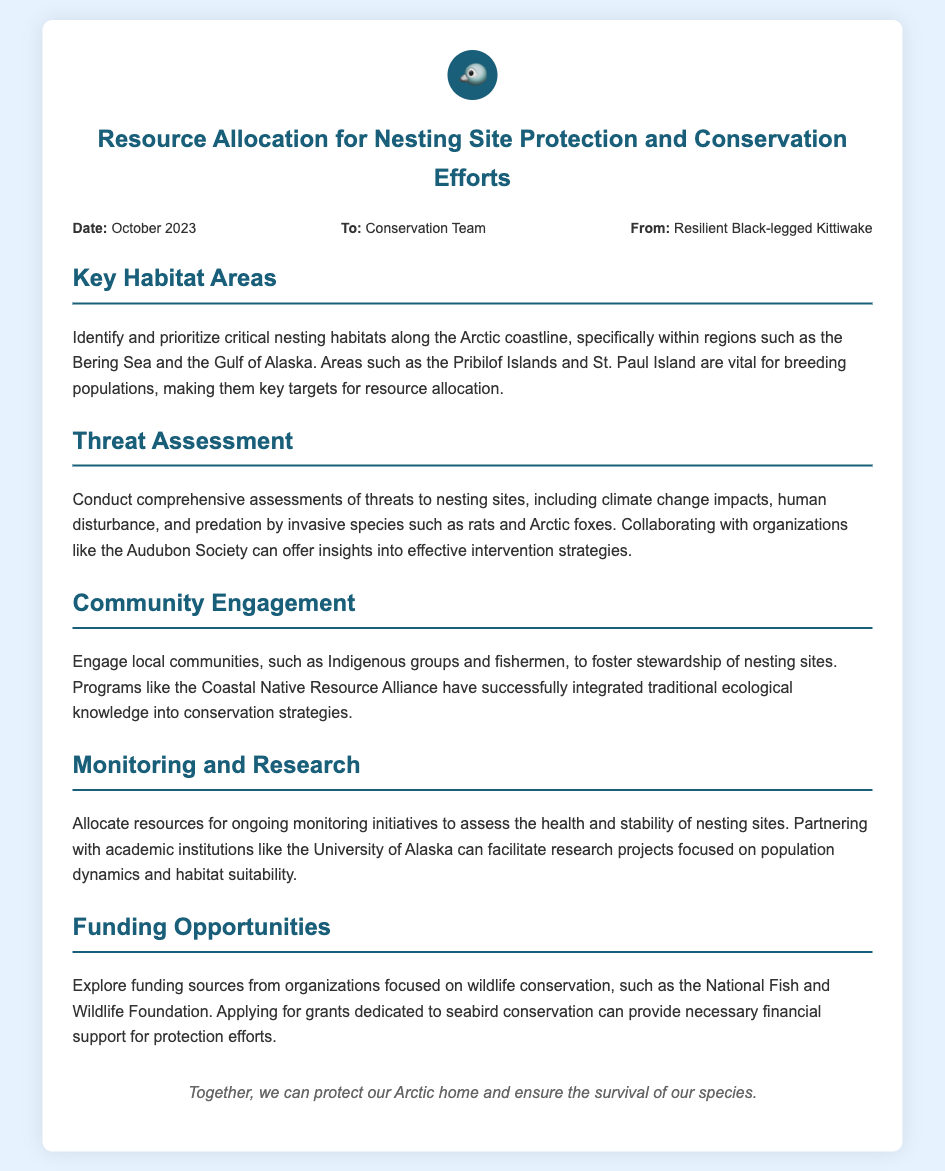What are the key habitat areas for nesting? The memo identifies regions such as the Bering Sea and the Gulf of Alaska, specifically mentioning the Pribilof Islands and St. Paul Island as vital for breeding populations.
Answer: Bering Sea, Gulf of Alaska, Pribilof Islands, St. Paul Island What is included in the threat assessment? The threat assessment covers threats like climate change impacts, human disturbance, and predation by invasive species such as rats and Arctic foxes.
Answer: Climate change, human disturbance, predation Which organizations are mentioned for collaboration? The memo mentions collaborating with organizations like the Audubon Society and academic institutions such as the University of Alaska to gather insights and facilitate research.
Answer: Audubon Society, University of Alaska What community engagement program is referenced? The memo references the Coastal Native Resource Alliance as a successful program that integrates traditional ecological knowledge into conservation strategies.
Answer: Coastal Native Resource Alliance What is a suggested funding source for conservation efforts? The memo suggests exploring sources from organizations focused on wildlife conservation like the National Fish and Wildlife Foundation.
Answer: National Fish and Wildlife Foundation What type of monitoring initiatives are recommended? The memo allocates resources for ongoing monitoring initiatives to assess the health and stability of nesting sites.
Answer: Ongoing monitoring initiatives What is the purpose of this memo? The purpose of the memo is to outline resource allocation for the protection and conservation of nesting sites for the black-legged kittiwake.
Answer: Resource allocation for protection and conservation Who is the sender of the memo? The sender of the memo is identified as the Resilient Black-legged Kittiwake.
Answer: Resilient Black-legged Kittiwake 